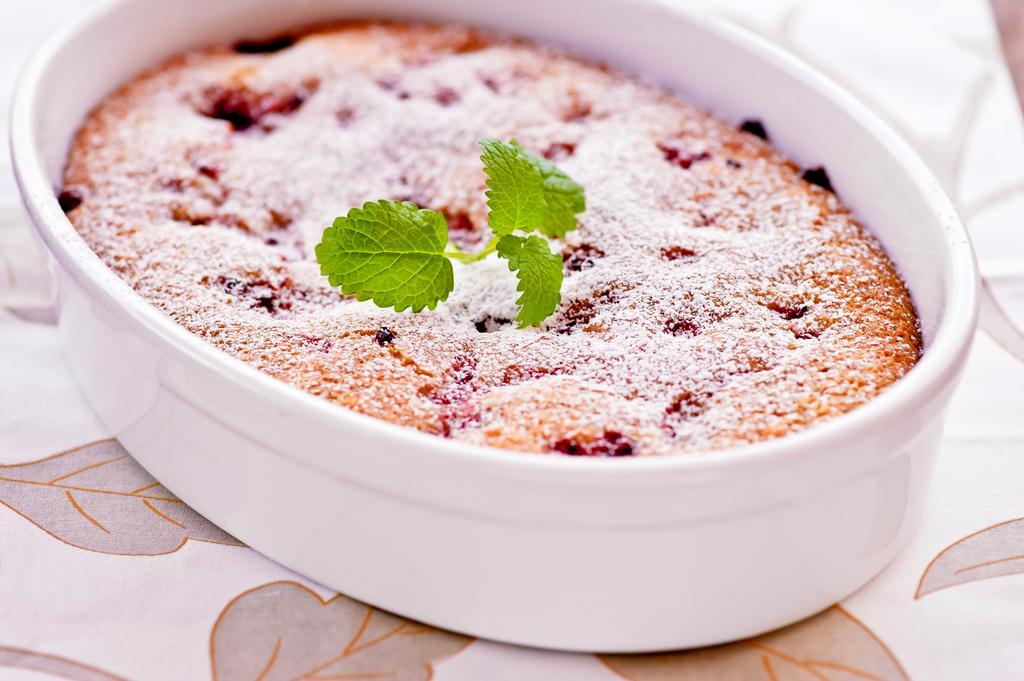Describe this image in one or two sentences. In this picture, we see the bowl containing the food item and the mint leaves is placed on the table which is covered with the white cloth. 